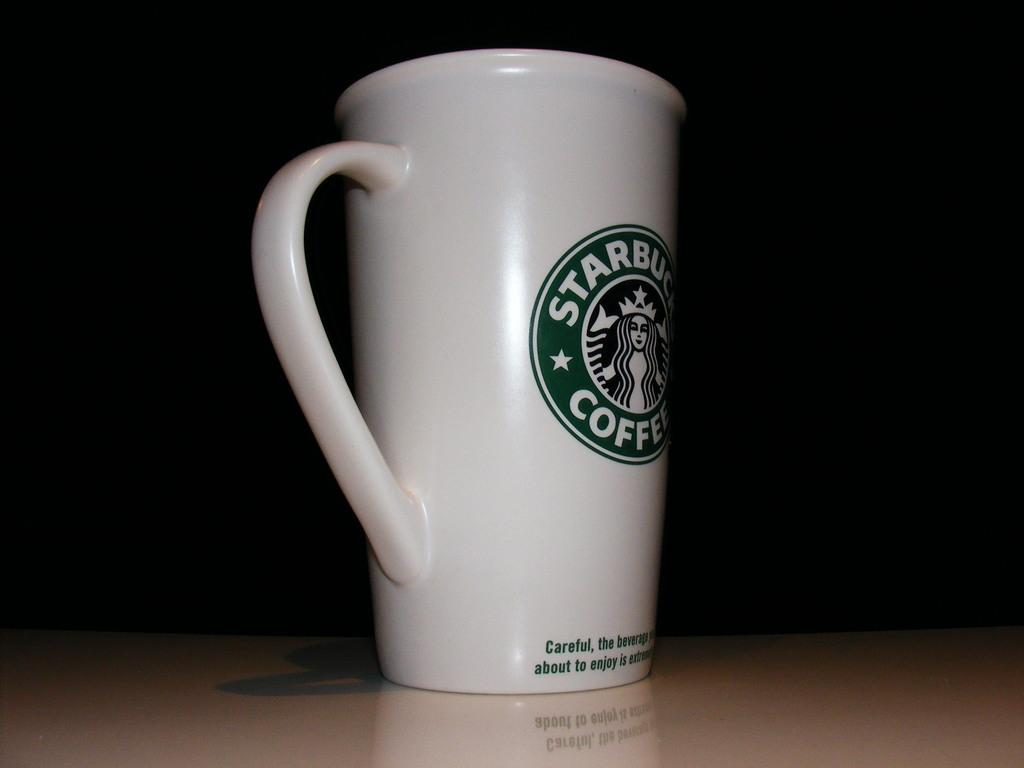<image>
Present a compact description of the photo's key features. A tall coffee mug with the logo for star bucks coffee on the center. 